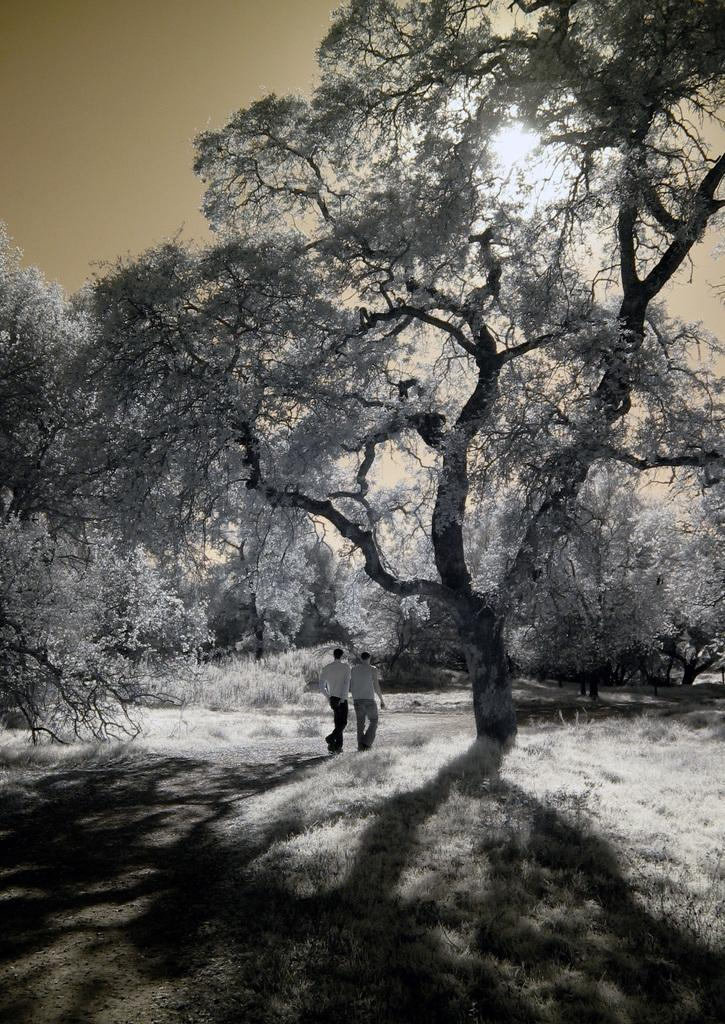What is the most prominent feature in the image? There is a huge tree in the image. What are the two men in the image doing? The two men are walking in the image. What color is the sky in the image? The sky is blue in the image. How is the fog affecting the visibility of the women in the image? There are no women or fog present in the image. What is the distribution of the women in the image? There are no women present in the image, so their distribution cannot be determined. 